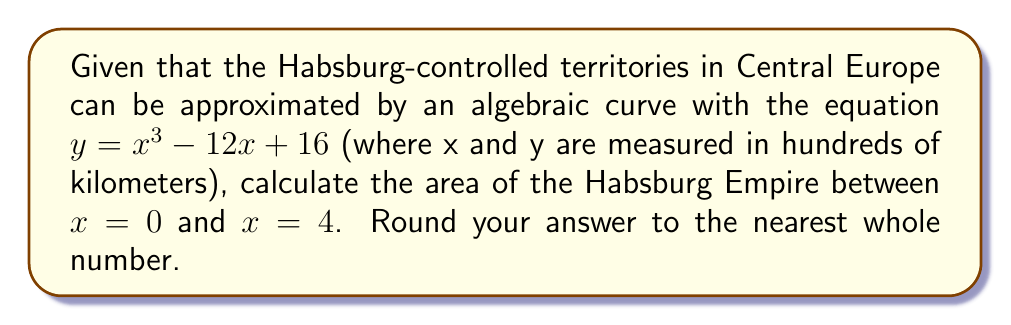What is the answer to this math problem? To calculate the area under the curve, we need to use definite integration:

1) The area is given by the integral:
   $$A = \int_{0}^{4} (x^3 - 12x + 16) dx$$

2) Integrate the function:
   $$A = [\frac{1}{4}x^4 - 6x^2 + 16x]_{0}^{4}$$

3) Evaluate the integral at the limits:
   $$A = (\frac{1}{4}(4^4) - 6(4^2) + 16(4)) - (\frac{1}{4}(0^4) - 6(0^2) + 16(0))$$
   $$A = (64 - 96 + 64) - (0 - 0 + 0)$$
   $$A = 32$$

4) Convert to square kilometers:
   Since x and y were measured in hundreds of kilometers, we need to multiply our result by 10,000 to get the area in square kilometers.
   $$A = 32 * 10,000 = 320,000 \text{ km}^2$$

5) Rounding to the nearest whole number:
   The area is already a whole number, so no rounding is necessary.
Answer: 320,000 km² 